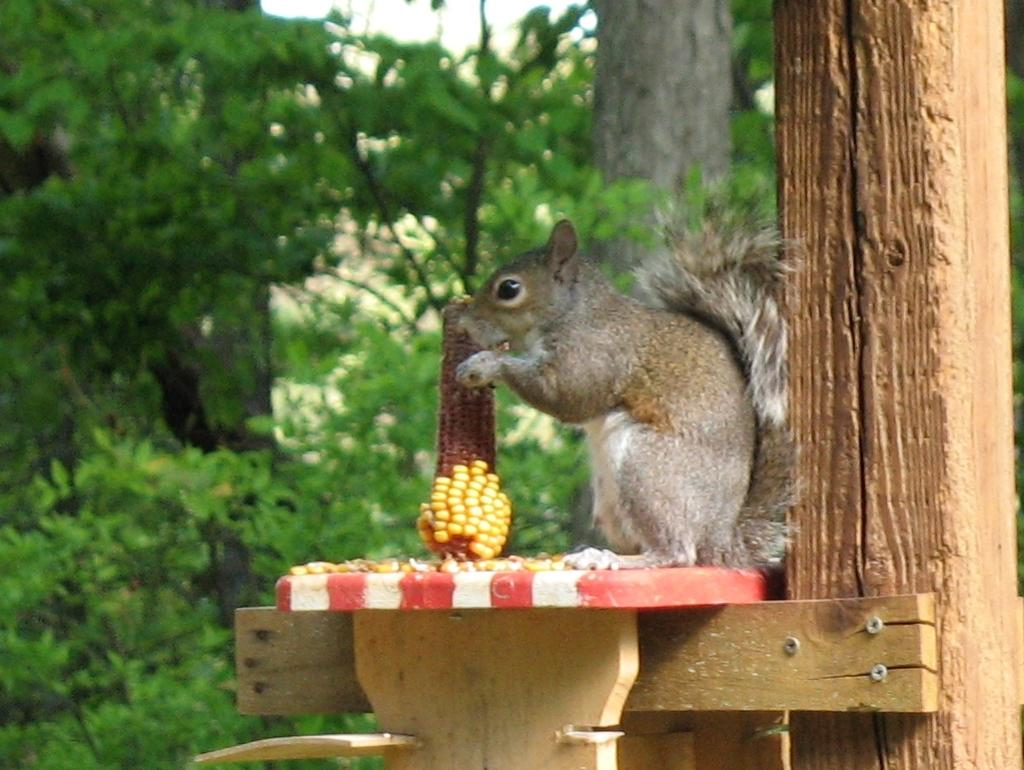What animal can be seen in the image? There is a squirrel in the image. Where is the squirrel located? The squirrel is sitting on a bench. What is the squirrel holding in its hands? The squirrel is holding corn in its hands. What can be seen in the background of the image? There is sky, trees, and a log visible in the background of the image. What type of cable is the squirrel using to connect to the internet in the image? There is no cable or internet connection present in the image; the squirrel is simply sitting on a bench holding corn. 